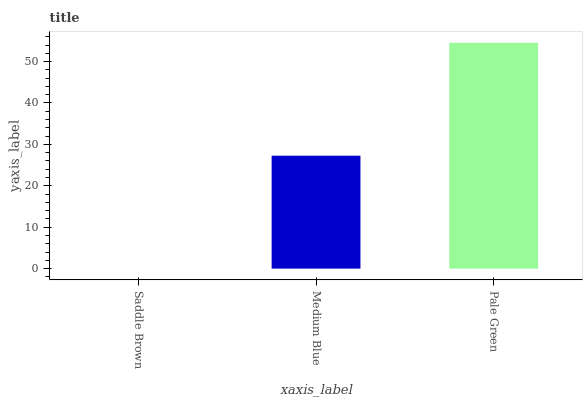Is Medium Blue the minimum?
Answer yes or no. No. Is Medium Blue the maximum?
Answer yes or no. No. Is Medium Blue greater than Saddle Brown?
Answer yes or no. Yes. Is Saddle Brown less than Medium Blue?
Answer yes or no. Yes. Is Saddle Brown greater than Medium Blue?
Answer yes or no. No. Is Medium Blue less than Saddle Brown?
Answer yes or no. No. Is Medium Blue the high median?
Answer yes or no. Yes. Is Medium Blue the low median?
Answer yes or no. Yes. Is Pale Green the high median?
Answer yes or no. No. Is Pale Green the low median?
Answer yes or no. No. 